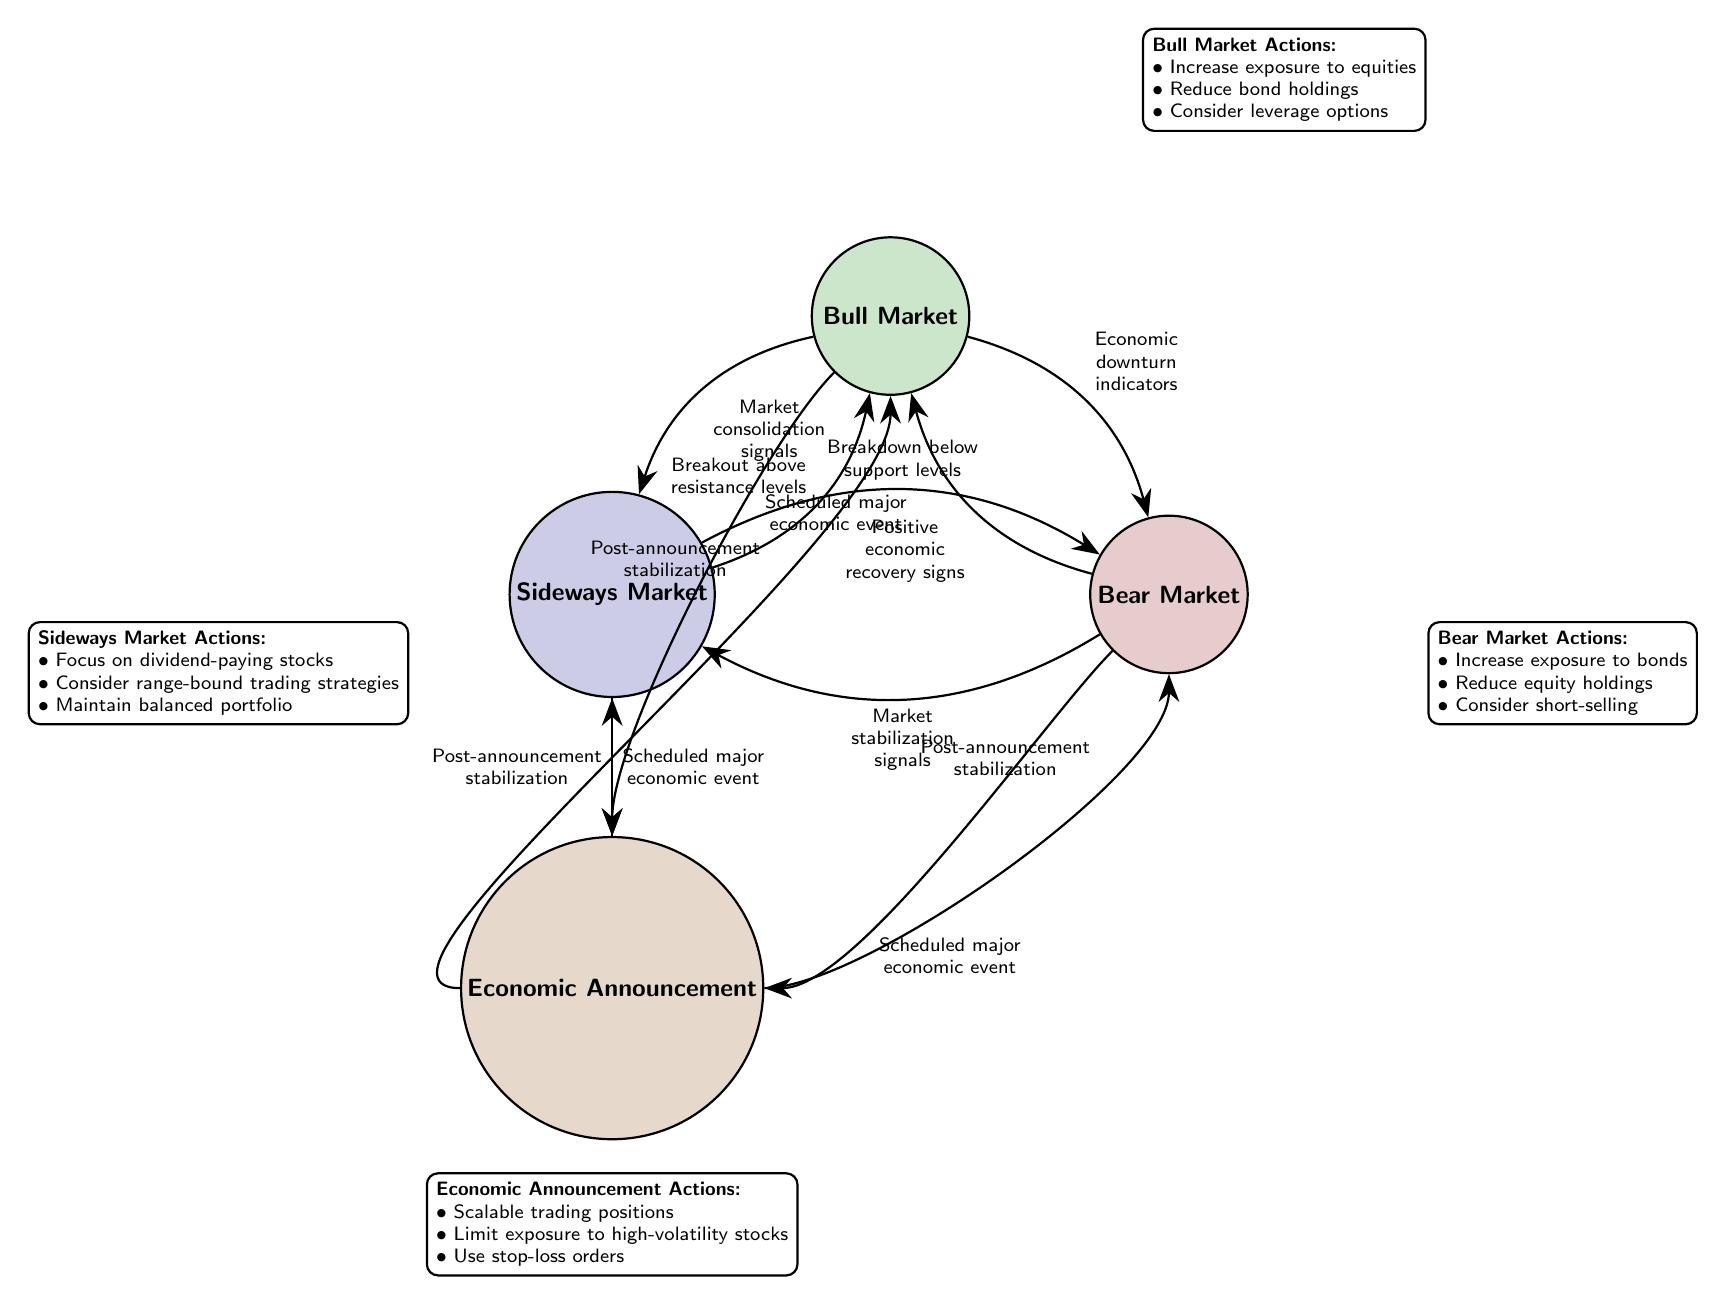What are the states in the diagram? The diagram features four states: Bull Market, Bear Market, Sideways Market, and Economic Announcement.
Answer: Bull Market, Bear Market, Sideways Market, Economic Announcement How many actions are listed under Bear Market? The Bear Market state has three actions outlined: Increase exposure to bonds, Reduce equity holdings, and Consider short-selling.
Answer: 3 What transition occurs from Bull Market to Bear Market? The transition from Bull Market to Bear Market is triggered by economic downturn indicators.
Answer: Economic downturn indicators What actions should be taken in a Sideways Market? In a Sideways Market, the actions recommended are to focus on dividend-paying stocks, consider range-bound trading strategies, and maintain a balanced portfolio.
Answer: Focus on dividend-paying stocks, consider range-bound trading strategies, maintain balanced portfolio Which state do you transition to after an Economic Announcement if the market stabilizes? After an Economic Announcement, if the market stabilizes, you can transition to either Bull Market, Bear Market, or Sideways Market depending on the conditions.
Answer: Bull Market, Bear Market, Sideways Market Which state indicates a strong upward trend in the market? A strong upward trend in the market is indicated by the Bull Market state, characterized by rising stock prices.
Answer: Bull Market How can one transition from Sideways Market to Bear Market? Transitioning from Sideways Market to Bear Market occurs following a breakdown below support levels.
Answer: Breakdown below support levels What is the action to take during an Economic Announcement? During an Economic Announcement, it's advised to limit exposure to high-volatility stocks and use stop-loss orders, among other actions.
Answer: Limit exposure to high-volatility stocks, use stop-loss orders What trigger would cause a transition from Bear Market back to Bull Market? A transition from Bear Market back to Bull Market would be triggered by positive economic recovery signs.
Answer: Positive economic recovery signs 